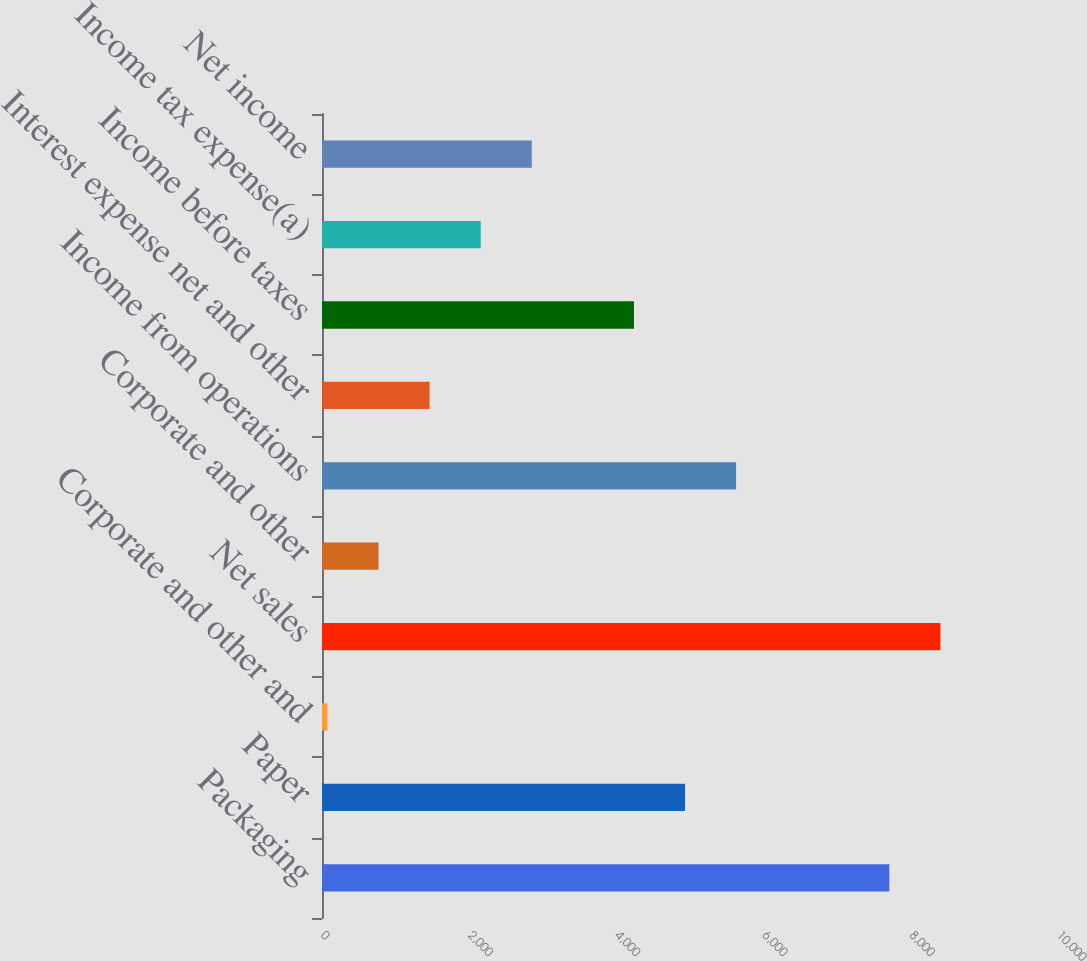Convert chart to OTSL. <chart><loc_0><loc_0><loc_500><loc_500><bar_chart><fcel>Packaging<fcel>Paper<fcel>Corporate and other and<fcel>Net sales<fcel>Corporate and other<fcel>Income from operations<fcel>Interest expense net and other<fcel>Income before taxes<fcel>Income tax expense(a)<fcel>Net income<nl><fcel>7708.65<fcel>4932.45<fcel>74.1<fcel>8402.7<fcel>768.15<fcel>5626.5<fcel>1462.2<fcel>4238.4<fcel>2156.25<fcel>2850.3<nl></chart> 